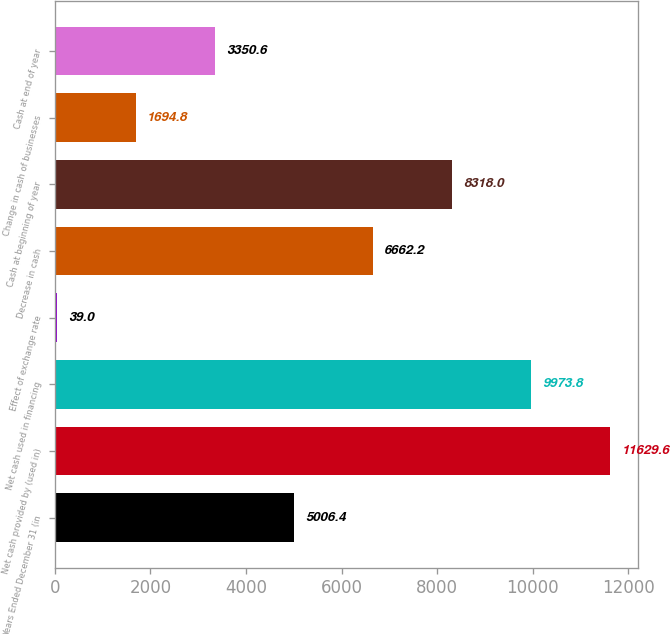<chart> <loc_0><loc_0><loc_500><loc_500><bar_chart><fcel>Years Ended December 31 (in<fcel>Net cash provided by (used in)<fcel>Net cash used in financing<fcel>Effect of exchange rate<fcel>Decrease in cash<fcel>Cash at beginning of year<fcel>Change in cash of businesses<fcel>Cash at end of year<nl><fcel>5006.4<fcel>11629.6<fcel>9973.8<fcel>39<fcel>6662.2<fcel>8318<fcel>1694.8<fcel>3350.6<nl></chart> 